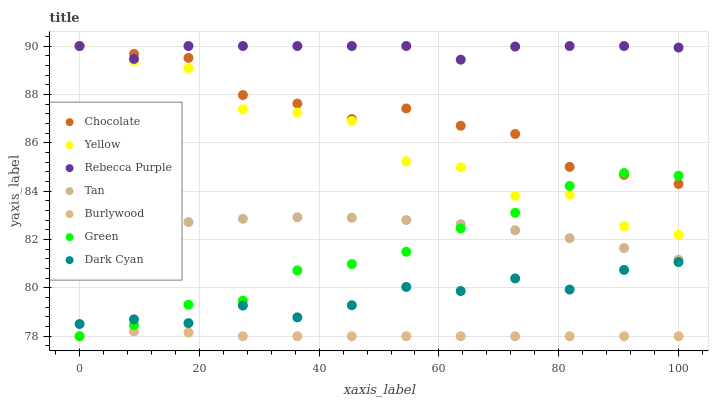Does Burlywood have the minimum area under the curve?
Answer yes or no. Yes. Does Rebecca Purple have the maximum area under the curve?
Answer yes or no. Yes. Does Yellow have the minimum area under the curve?
Answer yes or no. No. Does Yellow have the maximum area under the curve?
Answer yes or no. No. Is Burlywood the smoothest?
Answer yes or no. Yes. Is Yellow the roughest?
Answer yes or no. Yes. Is Chocolate the smoothest?
Answer yes or no. No. Is Chocolate the roughest?
Answer yes or no. No. Does Burlywood have the lowest value?
Answer yes or no. Yes. Does Yellow have the lowest value?
Answer yes or no. No. Does Rebecca Purple have the highest value?
Answer yes or no. Yes. Does Green have the highest value?
Answer yes or no. No. Is Dark Cyan less than Rebecca Purple?
Answer yes or no. Yes. Is Chocolate greater than Tan?
Answer yes or no. Yes. Does Chocolate intersect Green?
Answer yes or no. Yes. Is Chocolate less than Green?
Answer yes or no. No. Is Chocolate greater than Green?
Answer yes or no. No. Does Dark Cyan intersect Rebecca Purple?
Answer yes or no. No. 